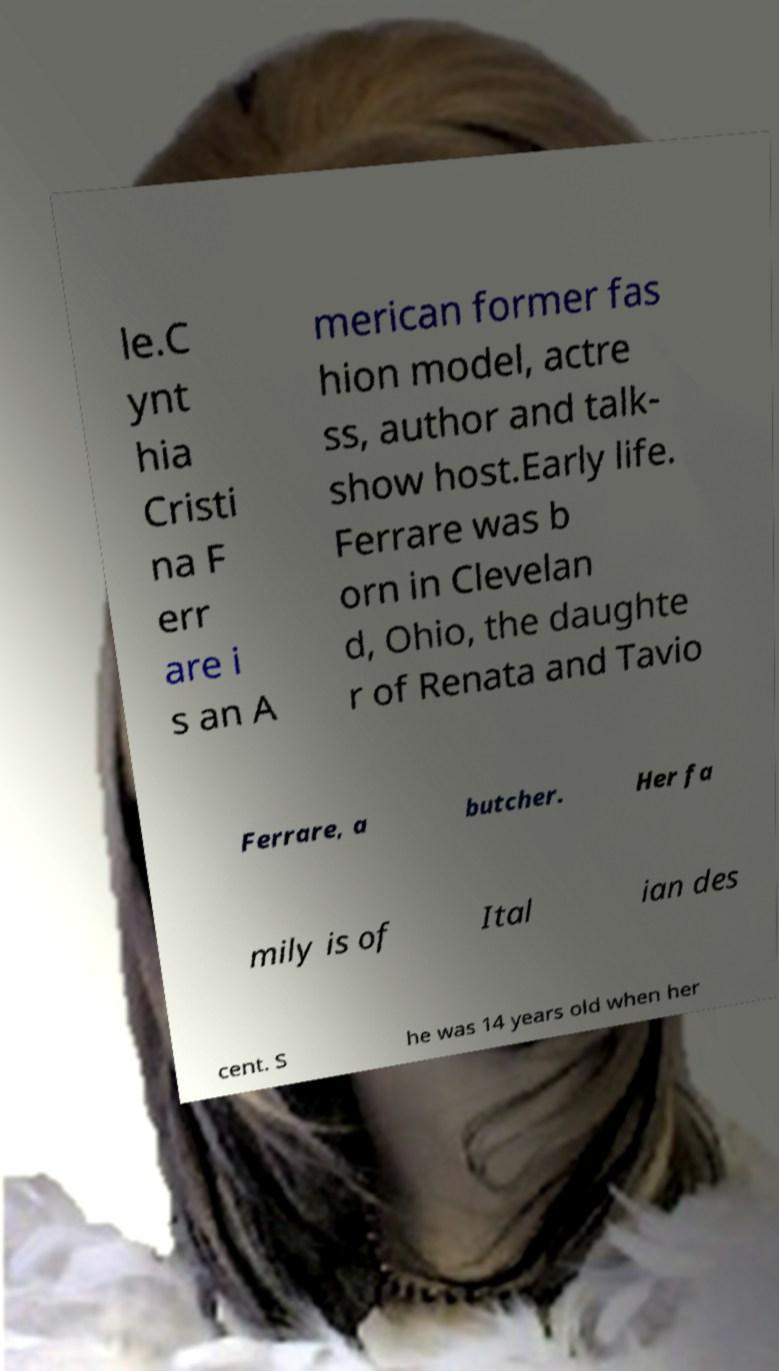There's text embedded in this image that I need extracted. Can you transcribe it verbatim? le.C ynt hia Cristi na F err are i s an A merican former fas hion model, actre ss, author and talk- show host.Early life. Ferrare was b orn in Clevelan d, Ohio, the daughte r of Renata and Tavio Ferrare, a butcher. Her fa mily is of Ital ian des cent. S he was 14 years old when her 